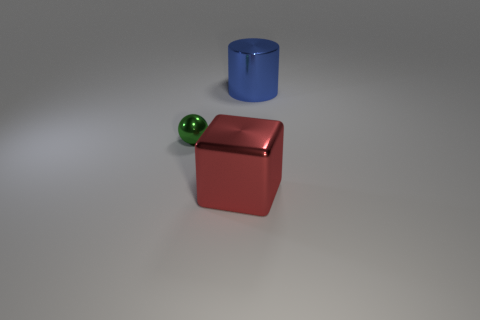Does the thing behind the small green metal thing have the same size as the thing in front of the green shiny thing?
Ensure brevity in your answer.  Yes. How many large red objects are there?
Provide a short and direct response. 1. How many blue cylinders are the same material as the red cube?
Your response must be concise. 1. Are there an equal number of objects that are left of the red thing and big blocks?
Provide a succinct answer. Yes. Is the size of the red metallic block the same as the object that is behind the small green thing?
Offer a terse response. Yes. What number of other things are there of the same size as the red block?
Your answer should be compact. 1. How many other objects are the same color as the small sphere?
Offer a terse response. 0. Is there anything else that is the same size as the green thing?
Ensure brevity in your answer.  No. What number of other things are the same shape as the red metallic thing?
Offer a terse response. 0. Does the shiny ball have the same size as the red metallic cube?
Offer a terse response. No. 